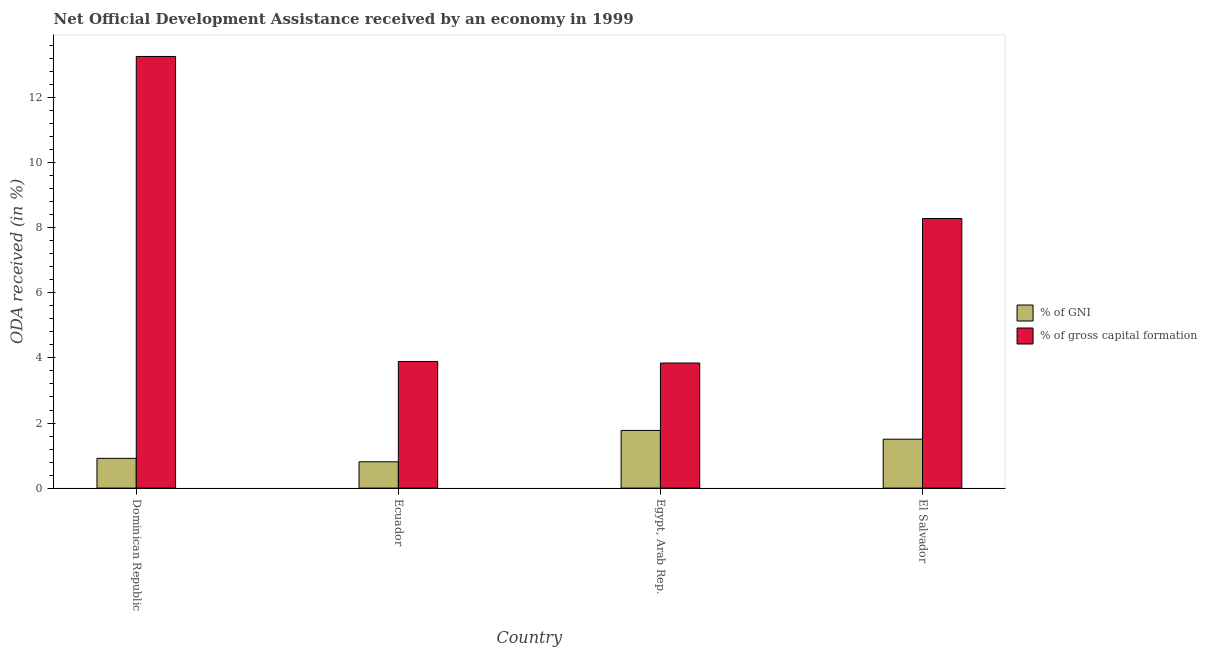How many different coloured bars are there?
Offer a terse response. 2. Are the number of bars per tick equal to the number of legend labels?
Your answer should be very brief. Yes. What is the label of the 2nd group of bars from the left?
Your answer should be very brief. Ecuador. What is the oda received as percentage of gni in Dominican Republic?
Your answer should be compact. 0.91. Across all countries, what is the maximum oda received as percentage of gross capital formation?
Make the answer very short. 13.27. Across all countries, what is the minimum oda received as percentage of gni?
Offer a very short reply. 0.81. In which country was the oda received as percentage of gni maximum?
Keep it short and to the point. Egypt, Arab Rep. In which country was the oda received as percentage of gross capital formation minimum?
Your answer should be compact. Egypt, Arab Rep. What is the total oda received as percentage of gni in the graph?
Offer a terse response. 5. What is the difference between the oda received as percentage of gni in Dominican Republic and that in Egypt, Arab Rep.?
Offer a terse response. -0.86. What is the difference between the oda received as percentage of gni in El Salvador and the oda received as percentage of gross capital formation in Egypt, Arab Rep.?
Your answer should be very brief. -2.34. What is the average oda received as percentage of gross capital formation per country?
Your answer should be very brief. 7.32. What is the difference between the oda received as percentage of gross capital formation and oda received as percentage of gni in El Salvador?
Your answer should be very brief. 6.78. In how many countries, is the oda received as percentage of gni greater than 2.8 %?
Offer a very short reply. 0. What is the ratio of the oda received as percentage of gni in Ecuador to that in El Salvador?
Give a very brief answer. 0.54. Is the oda received as percentage of gross capital formation in Dominican Republic less than that in El Salvador?
Offer a terse response. No. Is the difference between the oda received as percentage of gni in Dominican Republic and Ecuador greater than the difference between the oda received as percentage of gross capital formation in Dominican Republic and Ecuador?
Offer a terse response. No. What is the difference between the highest and the second highest oda received as percentage of gross capital formation?
Keep it short and to the point. 4.98. What is the difference between the highest and the lowest oda received as percentage of gross capital formation?
Keep it short and to the point. 9.42. What does the 2nd bar from the left in Dominican Republic represents?
Offer a terse response. % of gross capital formation. What does the 2nd bar from the right in Ecuador represents?
Keep it short and to the point. % of GNI. What is the difference between two consecutive major ticks on the Y-axis?
Give a very brief answer. 2. Does the graph contain any zero values?
Give a very brief answer. No. What is the title of the graph?
Provide a succinct answer. Net Official Development Assistance received by an economy in 1999. What is the label or title of the X-axis?
Your answer should be compact. Country. What is the label or title of the Y-axis?
Your answer should be compact. ODA received (in %). What is the ODA received (in %) of % of GNI in Dominican Republic?
Provide a short and direct response. 0.91. What is the ODA received (in %) in % of gross capital formation in Dominican Republic?
Ensure brevity in your answer.  13.27. What is the ODA received (in %) in % of GNI in Ecuador?
Give a very brief answer. 0.81. What is the ODA received (in %) in % of gross capital formation in Ecuador?
Give a very brief answer. 3.89. What is the ODA received (in %) in % of GNI in Egypt, Arab Rep.?
Ensure brevity in your answer.  1.77. What is the ODA received (in %) of % of gross capital formation in Egypt, Arab Rep.?
Make the answer very short. 3.84. What is the ODA received (in %) of % of GNI in El Salvador?
Offer a terse response. 1.5. What is the ODA received (in %) in % of gross capital formation in El Salvador?
Provide a short and direct response. 8.29. Across all countries, what is the maximum ODA received (in %) of % of GNI?
Provide a short and direct response. 1.77. Across all countries, what is the maximum ODA received (in %) of % of gross capital formation?
Provide a succinct answer. 13.27. Across all countries, what is the minimum ODA received (in %) of % of GNI?
Your response must be concise. 0.81. Across all countries, what is the minimum ODA received (in %) in % of gross capital formation?
Give a very brief answer. 3.84. What is the total ODA received (in %) of % of GNI in the graph?
Give a very brief answer. 5. What is the total ODA received (in %) of % of gross capital formation in the graph?
Your answer should be compact. 29.29. What is the difference between the ODA received (in %) in % of GNI in Dominican Republic and that in Ecuador?
Offer a very short reply. 0.11. What is the difference between the ODA received (in %) of % of gross capital formation in Dominican Republic and that in Ecuador?
Ensure brevity in your answer.  9.38. What is the difference between the ODA received (in %) in % of GNI in Dominican Republic and that in Egypt, Arab Rep.?
Your answer should be very brief. -0.86. What is the difference between the ODA received (in %) in % of gross capital formation in Dominican Republic and that in Egypt, Arab Rep.?
Keep it short and to the point. 9.42. What is the difference between the ODA received (in %) in % of GNI in Dominican Republic and that in El Salvador?
Your answer should be compact. -0.59. What is the difference between the ODA received (in %) of % of gross capital formation in Dominican Republic and that in El Salvador?
Make the answer very short. 4.98. What is the difference between the ODA received (in %) of % of GNI in Ecuador and that in Egypt, Arab Rep.?
Keep it short and to the point. -0.96. What is the difference between the ODA received (in %) of % of gross capital formation in Ecuador and that in Egypt, Arab Rep.?
Your response must be concise. 0.05. What is the difference between the ODA received (in %) in % of GNI in Ecuador and that in El Salvador?
Provide a short and direct response. -0.69. What is the difference between the ODA received (in %) of % of gross capital formation in Ecuador and that in El Salvador?
Your response must be concise. -4.39. What is the difference between the ODA received (in %) of % of GNI in Egypt, Arab Rep. and that in El Salvador?
Provide a succinct answer. 0.27. What is the difference between the ODA received (in %) in % of gross capital formation in Egypt, Arab Rep. and that in El Salvador?
Make the answer very short. -4.44. What is the difference between the ODA received (in %) of % of GNI in Dominican Republic and the ODA received (in %) of % of gross capital formation in Ecuador?
Offer a terse response. -2.98. What is the difference between the ODA received (in %) of % of GNI in Dominican Republic and the ODA received (in %) of % of gross capital formation in Egypt, Arab Rep.?
Provide a short and direct response. -2.93. What is the difference between the ODA received (in %) in % of GNI in Dominican Republic and the ODA received (in %) in % of gross capital formation in El Salvador?
Keep it short and to the point. -7.37. What is the difference between the ODA received (in %) in % of GNI in Ecuador and the ODA received (in %) in % of gross capital formation in Egypt, Arab Rep.?
Ensure brevity in your answer.  -3.04. What is the difference between the ODA received (in %) of % of GNI in Ecuador and the ODA received (in %) of % of gross capital formation in El Salvador?
Ensure brevity in your answer.  -7.48. What is the difference between the ODA received (in %) of % of GNI in Egypt, Arab Rep. and the ODA received (in %) of % of gross capital formation in El Salvador?
Your response must be concise. -6.51. What is the average ODA received (in %) of % of GNI per country?
Offer a very short reply. 1.25. What is the average ODA received (in %) in % of gross capital formation per country?
Your response must be concise. 7.32. What is the difference between the ODA received (in %) in % of GNI and ODA received (in %) in % of gross capital formation in Dominican Republic?
Your answer should be compact. -12.35. What is the difference between the ODA received (in %) in % of GNI and ODA received (in %) in % of gross capital formation in Ecuador?
Make the answer very short. -3.08. What is the difference between the ODA received (in %) of % of GNI and ODA received (in %) of % of gross capital formation in Egypt, Arab Rep.?
Your response must be concise. -2.07. What is the difference between the ODA received (in %) of % of GNI and ODA received (in %) of % of gross capital formation in El Salvador?
Ensure brevity in your answer.  -6.78. What is the ratio of the ODA received (in %) in % of GNI in Dominican Republic to that in Ecuador?
Make the answer very short. 1.13. What is the ratio of the ODA received (in %) of % of gross capital formation in Dominican Republic to that in Ecuador?
Keep it short and to the point. 3.41. What is the ratio of the ODA received (in %) of % of GNI in Dominican Republic to that in Egypt, Arab Rep.?
Offer a terse response. 0.52. What is the ratio of the ODA received (in %) in % of gross capital formation in Dominican Republic to that in Egypt, Arab Rep.?
Your answer should be very brief. 3.45. What is the ratio of the ODA received (in %) of % of GNI in Dominican Republic to that in El Salvador?
Make the answer very short. 0.61. What is the ratio of the ODA received (in %) in % of gross capital formation in Dominican Republic to that in El Salvador?
Ensure brevity in your answer.  1.6. What is the ratio of the ODA received (in %) in % of GNI in Ecuador to that in Egypt, Arab Rep.?
Offer a terse response. 0.46. What is the ratio of the ODA received (in %) in % of gross capital formation in Ecuador to that in Egypt, Arab Rep.?
Provide a succinct answer. 1.01. What is the ratio of the ODA received (in %) of % of GNI in Ecuador to that in El Salvador?
Your answer should be very brief. 0.54. What is the ratio of the ODA received (in %) of % of gross capital formation in Ecuador to that in El Salvador?
Keep it short and to the point. 0.47. What is the ratio of the ODA received (in %) of % of GNI in Egypt, Arab Rep. to that in El Salvador?
Your answer should be compact. 1.18. What is the ratio of the ODA received (in %) in % of gross capital formation in Egypt, Arab Rep. to that in El Salvador?
Provide a short and direct response. 0.46. What is the difference between the highest and the second highest ODA received (in %) of % of GNI?
Offer a very short reply. 0.27. What is the difference between the highest and the second highest ODA received (in %) in % of gross capital formation?
Your answer should be compact. 4.98. What is the difference between the highest and the lowest ODA received (in %) in % of GNI?
Make the answer very short. 0.96. What is the difference between the highest and the lowest ODA received (in %) in % of gross capital formation?
Provide a short and direct response. 9.42. 